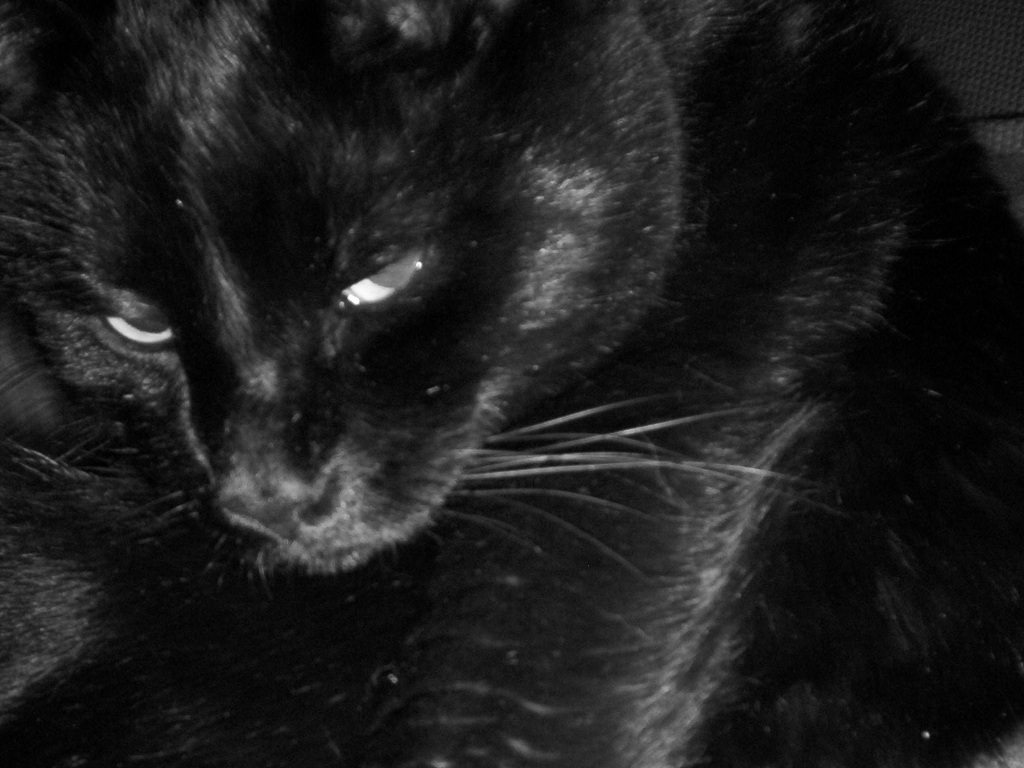This image is in black and white. How would coloring affect the perception of the image? If this image were in color, it could potentially offer a more realistic and warm feel, exposing the nuances in the cat's fur and the environment around it. Colors could also affect the viewers' emotional response to the image, perhaps making it feel more intimate and less abstract than the current monochromatic scheme. 